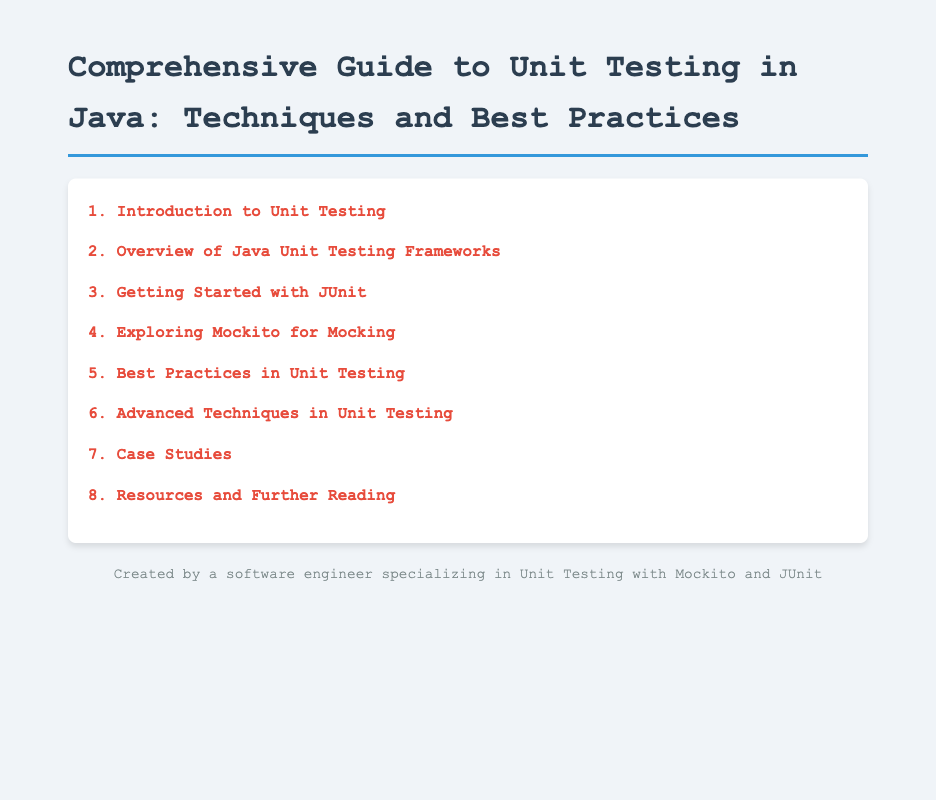What is the first section of the document? The first section of the document is listed as "1. Introduction to Unit Testing."
Answer: 1. Introduction to Unit Testing How many subsections are under the "Best Practices in Unit Testing"? The "Best Practices in Unit Testing" section contains three subsections.
Answer: 3 What is the title of the second subsection in the "Overview of Java Unit Testing Frameworks"? The second subsection is titled "Mockito: Simplifying Mocking."
Answer: Mockito: Simplifying Mocking Which section discusses "Parameterized Tests in JUnit"? "Parameterized Tests in JUnit" is discussed in the "Advanced Techniques in Unit Testing" section.
Answer: Advanced Techniques in Unit Testing What is the last subsection in the "Resources and Further Reading"? The last subsection is titled "Recommended Books and Articles."
Answer: Recommended Books and Articles 